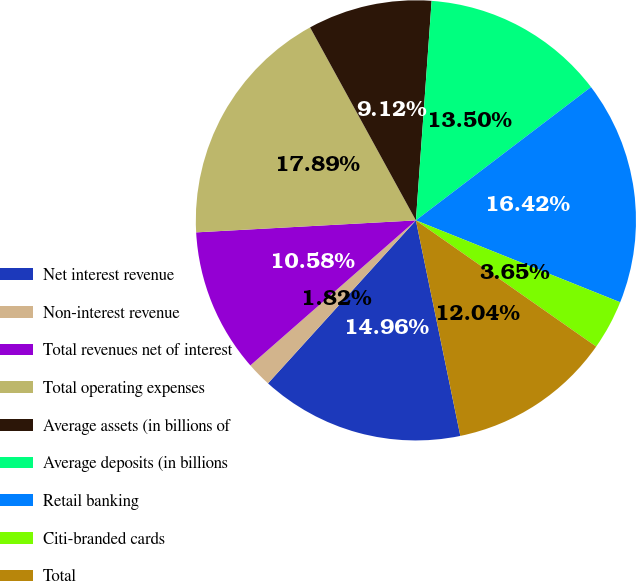<chart> <loc_0><loc_0><loc_500><loc_500><pie_chart><fcel>Net interest revenue<fcel>Non-interest revenue<fcel>Total revenues net of interest<fcel>Total operating expenses<fcel>Average assets (in billions of<fcel>Average deposits (in billions<fcel>Retail banking<fcel>Citi-branded cards<fcel>Total<nl><fcel>14.96%<fcel>1.82%<fcel>10.58%<fcel>17.88%<fcel>9.12%<fcel>13.5%<fcel>16.42%<fcel>3.65%<fcel>12.04%<nl></chart> 